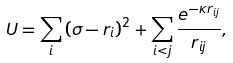Convert formula to latex. <formula><loc_0><loc_0><loc_500><loc_500>U = \sum _ { i } \left ( \sigma - r _ { i } \right ) ^ { 2 } + \sum _ { i < j } \frac { e ^ { - \kappa r _ { i j } } } { r _ { i j } } ,</formula> 